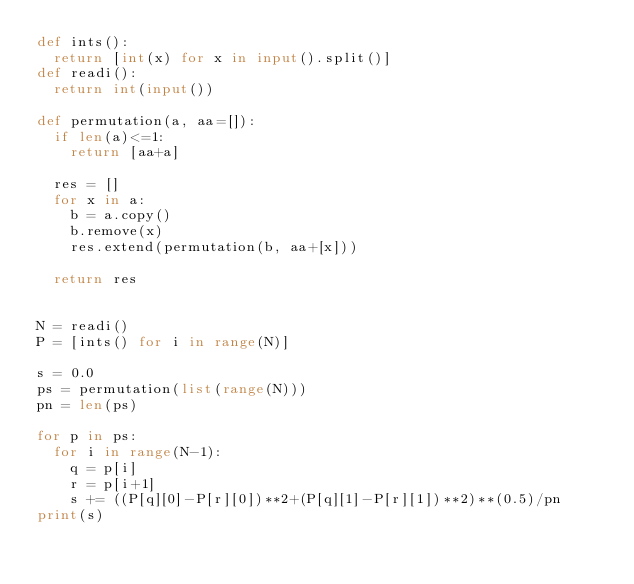<code> <loc_0><loc_0><loc_500><loc_500><_Python_>def ints():
  return [int(x) for x in input().split()]
def readi():
  return int(input())

def permutation(a, aa=[]):
  if len(a)<=1:
    return [aa+a]

  res = []
  for x in a:
    b = a.copy()
    b.remove(x)
    res.extend(permutation(b, aa+[x]))

  return res


N = readi()
P = [ints() for i in range(N)]

s = 0.0
ps = permutation(list(range(N)))
pn = len(ps)

for p in ps:
  for i in range(N-1):
    q = p[i]
    r = p[i+1]
    s += ((P[q][0]-P[r][0])**2+(P[q][1]-P[r][1])**2)**(0.5)/pn
print(s)
</code> 